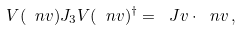Convert formula to latex. <formula><loc_0><loc_0><loc_500><loc_500>V ( \ n v ) J _ { 3 } V ( \ n v ) ^ { \dagger } = \ J v \cdot \ n v \, ,</formula> 